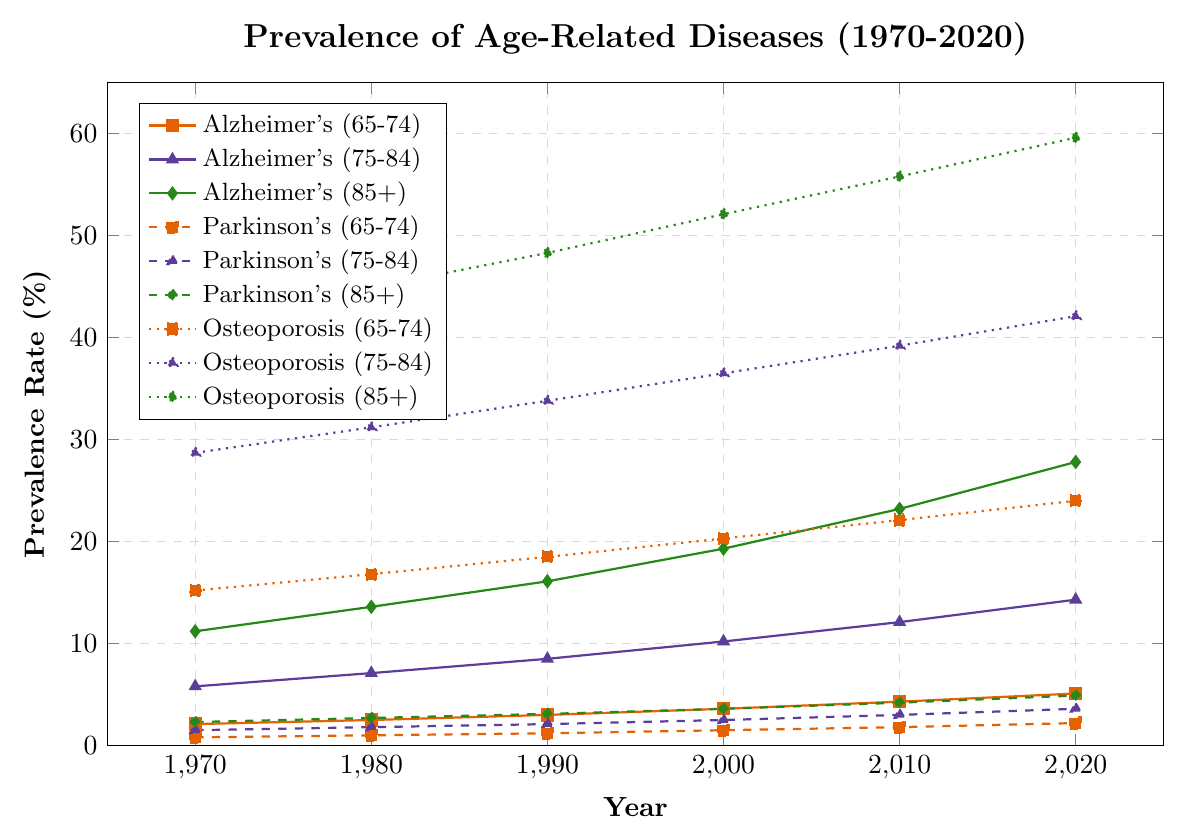How did the prevalence of Alzheimer's disease in the age group 85+ change from 1970 to 2020? To find the change, we subtract the 1970 prevalence rate from the 2020 prevalence rate for Alzheimer's in the age group 85+. The values are 27.8% (2020) and 11.2% (1970). So, 27.8 - 11.2 = 16.6.
Answer: 16.6 percentage points Which age group shows the highest prevalence rate for Parkinson's disease in 2020? To determine this, we look at the prevalence rates for Parkinson's disease across different age groups in the year 2020. The values are 2.2% (65-74), 3.6% (75-84), and 4.9% (85+). The highest value is 4.9% in the age group 85+.
Answer: 85+ Which disease shows the highest increase in prevalence rates for the age group 65-74 from 1970 to 2020? We need to calculate the difference in prevalence rates for each disease in the age group 65-74 from 1970 to 2020. Alzheimer's increases from 2.1% to 5.1% (5.1 - 2.1 = 3.0). Parkinson's increases from 0.8% to 2.2% (2.2 - 0.8 = 1.4). Osteoporosis increases from 15.2% to 24.0% (24.0 - 15.2 = 8.8). Osteoporosis has the highest increase.
Answer: Osteoporosis In which decade did the prevalence of Alzheimer's disease for the age group 75-84 see the greatest increase? To find the decade with the greatest increase, we compare decade-to-decade changes for Alzheimer's in the age group 75-84: (1980-1970: 7.1 - 5.8 = 1.3), (1990-1980: 8.5 - 7.1 = 1.4), (2000-1990: 10.2 - 8.5 = 1.7), (2010-2000: 12.1 - 10.2 = 1.9), (2020-2010: 14.3 - 12.1 = 2.2). The greatest increase of 2.2 occurred from 2010 to 2020.
Answer: 2010-2020 Compare the prevalence rates of Alzheimer's disease and Parkinson's disease for the age group 85+ in the year 2000. We refer to the values in the year 2000 for the age group 85+: Alzheimer's disease has a prevalence rate of 19.3%, and Parkinson's disease has a prevalence rate of 3.6%. Alzheimer's disease has a higher prevalence rate.
Answer: Alzheimer's disease What is the average prevalence rate of osteoporosis across all age groups in 2020? To find the average prevalence rate, sum the values for all age groups in 2020 and divide by the number of age groups. The values are 24.0% (65-74), 42.1% (75-84), and 59.6% (85+). (24.0 + 42.1 + 59.6) / 3 = 41.9.
Answer: 41.9% How does the prevalence rate of osteoporosis for the age group 65-74 in 1990 compare to that in 2010? We compare the values: in 1990, it is 18.5%, and in 2010, it is 22.1%. By subtracting the 1990 value from the 2010 value, we get 22.1 - 18.5 = 3.6. Osteoporosis prevalence increased by 3.6 percentage points.
Answer: Increased by 3.6 percentage points What is the maximum prevalence rate observed for any disease in the age group 85+ for any year? We need to identify the maximum value from all diseases in the age group 85+ across all years. The highest rates are Alzheimer's (27.8% in 2020), Parkinson's (4.9% in 2020), and Osteoporosis (59.6% in 2020). The maximum rate is 59.6% for Osteoporosis in 2020.
Answer: 59.6% for Osteoporosis in 2020 What trend can be observed about the prevalence of Alzheimer's disease across all age groups over the 50-year period? Observing the trend lines for Alzheimer's disease, we see that the prevalence rate for each age group increases over time from 1970 to 2020. The trend is consistently upward for all age groups.
Answer: Consistently increasing 